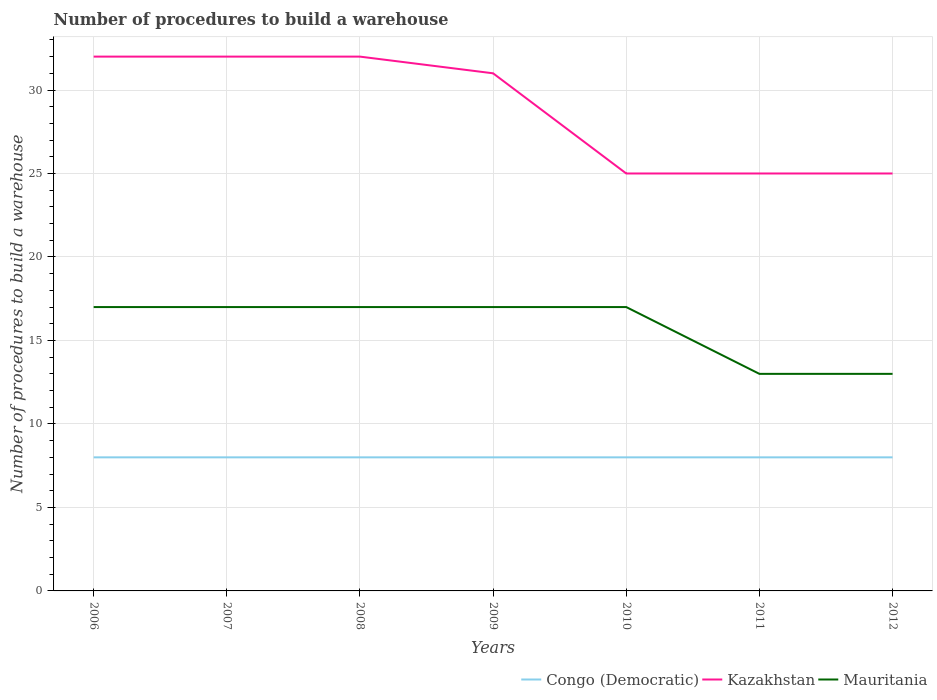Across all years, what is the maximum number of procedures to build a warehouse in in Kazakhstan?
Make the answer very short. 25. What is the total number of procedures to build a warehouse in in Kazakhstan in the graph?
Your response must be concise. 7. What is the difference between the highest and the second highest number of procedures to build a warehouse in in Mauritania?
Keep it short and to the point. 4. Is the number of procedures to build a warehouse in in Kazakhstan strictly greater than the number of procedures to build a warehouse in in Congo (Democratic) over the years?
Provide a succinct answer. No. Are the values on the major ticks of Y-axis written in scientific E-notation?
Offer a terse response. No. Does the graph contain any zero values?
Give a very brief answer. No. Does the graph contain grids?
Your answer should be very brief. Yes. Where does the legend appear in the graph?
Your answer should be very brief. Bottom right. How many legend labels are there?
Make the answer very short. 3. What is the title of the graph?
Offer a terse response. Number of procedures to build a warehouse. What is the label or title of the X-axis?
Provide a succinct answer. Years. What is the label or title of the Y-axis?
Your answer should be compact. Number of procedures to build a warehouse. What is the Number of procedures to build a warehouse in Congo (Democratic) in 2006?
Give a very brief answer. 8. What is the Number of procedures to build a warehouse of Mauritania in 2006?
Offer a terse response. 17. What is the Number of procedures to build a warehouse of Kazakhstan in 2008?
Your answer should be compact. 32. What is the Number of procedures to build a warehouse in Mauritania in 2008?
Your answer should be very brief. 17. What is the Number of procedures to build a warehouse in Congo (Democratic) in 2011?
Ensure brevity in your answer.  8. What is the Number of procedures to build a warehouse in Mauritania in 2011?
Give a very brief answer. 13. What is the Number of procedures to build a warehouse in Kazakhstan in 2012?
Give a very brief answer. 25. Across all years, what is the maximum Number of procedures to build a warehouse in Mauritania?
Your answer should be compact. 17. What is the total Number of procedures to build a warehouse in Congo (Democratic) in the graph?
Make the answer very short. 56. What is the total Number of procedures to build a warehouse in Kazakhstan in the graph?
Keep it short and to the point. 202. What is the total Number of procedures to build a warehouse of Mauritania in the graph?
Your response must be concise. 111. What is the difference between the Number of procedures to build a warehouse of Kazakhstan in 2006 and that in 2009?
Your answer should be very brief. 1. What is the difference between the Number of procedures to build a warehouse of Mauritania in 2006 and that in 2010?
Provide a short and direct response. 0. What is the difference between the Number of procedures to build a warehouse of Kazakhstan in 2006 and that in 2011?
Keep it short and to the point. 7. What is the difference between the Number of procedures to build a warehouse in Mauritania in 2006 and that in 2011?
Your answer should be compact. 4. What is the difference between the Number of procedures to build a warehouse of Congo (Democratic) in 2006 and that in 2012?
Your response must be concise. 0. What is the difference between the Number of procedures to build a warehouse of Mauritania in 2006 and that in 2012?
Offer a terse response. 4. What is the difference between the Number of procedures to build a warehouse in Congo (Democratic) in 2007 and that in 2008?
Your response must be concise. 0. What is the difference between the Number of procedures to build a warehouse of Congo (Democratic) in 2007 and that in 2009?
Your answer should be very brief. 0. What is the difference between the Number of procedures to build a warehouse of Congo (Democratic) in 2007 and that in 2010?
Make the answer very short. 0. What is the difference between the Number of procedures to build a warehouse in Kazakhstan in 2007 and that in 2011?
Offer a terse response. 7. What is the difference between the Number of procedures to build a warehouse in Mauritania in 2007 and that in 2011?
Offer a terse response. 4. What is the difference between the Number of procedures to build a warehouse in Congo (Democratic) in 2007 and that in 2012?
Provide a succinct answer. 0. What is the difference between the Number of procedures to build a warehouse in Congo (Democratic) in 2008 and that in 2009?
Provide a short and direct response. 0. What is the difference between the Number of procedures to build a warehouse of Congo (Democratic) in 2008 and that in 2012?
Offer a terse response. 0. What is the difference between the Number of procedures to build a warehouse of Kazakhstan in 2008 and that in 2012?
Your response must be concise. 7. What is the difference between the Number of procedures to build a warehouse in Congo (Democratic) in 2009 and that in 2010?
Give a very brief answer. 0. What is the difference between the Number of procedures to build a warehouse in Kazakhstan in 2009 and that in 2010?
Provide a succinct answer. 6. What is the difference between the Number of procedures to build a warehouse in Mauritania in 2009 and that in 2010?
Provide a succinct answer. 0. What is the difference between the Number of procedures to build a warehouse in Kazakhstan in 2009 and that in 2012?
Give a very brief answer. 6. What is the difference between the Number of procedures to build a warehouse in Congo (Democratic) in 2010 and that in 2011?
Offer a very short reply. 0. What is the difference between the Number of procedures to build a warehouse in Congo (Democratic) in 2010 and that in 2012?
Give a very brief answer. 0. What is the difference between the Number of procedures to build a warehouse in Kazakhstan in 2010 and that in 2012?
Provide a succinct answer. 0. What is the difference between the Number of procedures to build a warehouse of Congo (Democratic) in 2011 and that in 2012?
Your answer should be compact. 0. What is the difference between the Number of procedures to build a warehouse of Kazakhstan in 2011 and that in 2012?
Make the answer very short. 0. What is the difference between the Number of procedures to build a warehouse in Congo (Democratic) in 2006 and the Number of procedures to build a warehouse in Kazakhstan in 2007?
Ensure brevity in your answer.  -24. What is the difference between the Number of procedures to build a warehouse of Kazakhstan in 2006 and the Number of procedures to build a warehouse of Mauritania in 2007?
Offer a very short reply. 15. What is the difference between the Number of procedures to build a warehouse in Kazakhstan in 2006 and the Number of procedures to build a warehouse in Mauritania in 2008?
Provide a short and direct response. 15. What is the difference between the Number of procedures to build a warehouse in Congo (Democratic) in 2006 and the Number of procedures to build a warehouse in Kazakhstan in 2009?
Provide a short and direct response. -23. What is the difference between the Number of procedures to build a warehouse of Kazakhstan in 2006 and the Number of procedures to build a warehouse of Mauritania in 2009?
Provide a short and direct response. 15. What is the difference between the Number of procedures to build a warehouse in Congo (Democratic) in 2006 and the Number of procedures to build a warehouse in Kazakhstan in 2010?
Provide a short and direct response. -17. What is the difference between the Number of procedures to build a warehouse of Congo (Democratic) in 2006 and the Number of procedures to build a warehouse of Mauritania in 2010?
Keep it short and to the point. -9. What is the difference between the Number of procedures to build a warehouse of Kazakhstan in 2006 and the Number of procedures to build a warehouse of Mauritania in 2010?
Your answer should be very brief. 15. What is the difference between the Number of procedures to build a warehouse of Congo (Democratic) in 2006 and the Number of procedures to build a warehouse of Kazakhstan in 2012?
Provide a succinct answer. -17. What is the difference between the Number of procedures to build a warehouse of Congo (Democratic) in 2006 and the Number of procedures to build a warehouse of Mauritania in 2012?
Offer a terse response. -5. What is the difference between the Number of procedures to build a warehouse in Congo (Democratic) in 2007 and the Number of procedures to build a warehouse in Mauritania in 2008?
Provide a short and direct response. -9. What is the difference between the Number of procedures to build a warehouse in Congo (Democratic) in 2007 and the Number of procedures to build a warehouse in Kazakhstan in 2009?
Give a very brief answer. -23. What is the difference between the Number of procedures to build a warehouse of Congo (Democratic) in 2007 and the Number of procedures to build a warehouse of Mauritania in 2009?
Your answer should be compact. -9. What is the difference between the Number of procedures to build a warehouse of Congo (Democratic) in 2007 and the Number of procedures to build a warehouse of Kazakhstan in 2010?
Provide a succinct answer. -17. What is the difference between the Number of procedures to build a warehouse of Congo (Democratic) in 2007 and the Number of procedures to build a warehouse of Mauritania in 2010?
Offer a very short reply. -9. What is the difference between the Number of procedures to build a warehouse in Kazakhstan in 2007 and the Number of procedures to build a warehouse in Mauritania in 2010?
Give a very brief answer. 15. What is the difference between the Number of procedures to build a warehouse of Congo (Democratic) in 2007 and the Number of procedures to build a warehouse of Mauritania in 2011?
Make the answer very short. -5. What is the difference between the Number of procedures to build a warehouse in Congo (Democratic) in 2008 and the Number of procedures to build a warehouse in Kazakhstan in 2009?
Ensure brevity in your answer.  -23. What is the difference between the Number of procedures to build a warehouse in Congo (Democratic) in 2008 and the Number of procedures to build a warehouse in Mauritania in 2009?
Offer a terse response. -9. What is the difference between the Number of procedures to build a warehouse in Kazakhstan in 2008 and the Number of procedures to build a warehouse in Mauritania in 2009?
Keep it short and to the point. 15. What is the difference between the Number of procedures to build a warehouse in Congo (Democratic) in 2008 and the Number of procedures to build a warehouse in Kazakhstan in 2010?
Provide a short and direct response. -17. What is the difference between the Number of procedures to build a warehouse in Congo (Democratic) in 2008 and the Number of procedures to build a warehouse in Mauritania in 2010?
Keep it short and to the point. -9. What is the difference between the Number of procedures to build a warehouse in Kazakhstan in 2008 and the Number of procedures to build a warehouse in Mauritania in 2010?
Offer a very short reply. 15. What is the difference between the Number of procedures to build a warehouse in Congo (Democratic) in 2008 and the Number of procedures to build a warehouse in Kazakhstan in 2012?
Offer a very short reply. -17. What is the difference between the Number of procedures to build a warehouse of Congo (Democratic) in 2008 and the Number of procedures to build a warehouse of Mauritania in 2012?
Provide a succinct answer. -5. What is the difference between the Number of procedures to build a warehouse in Kazakhstan in 2008 and the Number of procedures to build a warehouse in Mauritania in 2012?
Give a very brief answer. 19. What is the difference between the Number of procedures to build a warehouse of Congo (Democratic) in 2009 and the Number of procedures to build a warehouse of Kazakhstan in 2010?
Provide a short and direct response. -17. What is the difference between the Number of procedures to build a warehouse in Congo (Democratic) in 2009 and the Number of procedures to build a warehouse in Mauritania in 2010?
Offer a terse response. -9. What is the difference between the Number of procedures to build a warehouse of Kazakhstan in 2009 and the Number of procedures to build a warehouse of Mauritania in 2010?
Keep it short and to the point. 14. What is the difference between the Number of procedures to build a warehouse in Congo (Democratic) in 2009 and the Number of procedures to build a warehouse in Kazakhstan in 2011?
Give a very brief answer. -17. What is the difference between the Number of procedures to build a warehouse of Congo (Democratic) in 2009 and the Number of procedures to build a warehouse of Mauritania in 2011?
Provide a short and direct response. -5. What is the difference between the Number of procedures to build a warehouse in Kazakhstan in 2009 and the Number of procedures to build a warehouse in Mauritania in 2011?
Offer a terse response. 18. What is the difference between the Number of procedures to build a warehouse in Congo (Democratic) in 2009 and the Number of procedures to build a warehouse in Kazakhstan in 2012?
Offer a terse response. -17. What is the difference between the Number of procedures to build a warehouse in Kazakhstan in 2009 and the Number of procedures to build a warehouse in Mauritania in 2012?
Your answer should be very brief. 18. What is the difference between the Number of procedures to build a warehouse of Congo (Democratic) in 2010 and the Number of procedures to build a warehouse of Mauritania in 2011?
Provide a short and direct response. -5. What is the difference between the Number of procedures to build a warehouse in Kazakhstan in 2010 and the Number of procedures to build a warehouse in Mauritania in 2011?
Offer a terse response. 12. What is the difference between the Number of procedures to build a warehouse of Congo (Democratic) in 2010 and the Number of procedures to build a warehouse of Mauritania in 2012?
Keep it short and to the point. -5. What is the difference between the Number of procedures to build a warehouse of Kazakhstan in 2010 and the Number of procedures to build a warehouse of Mauritania in 2012?
Make the answer very short. 12. What is the difference between the Number of procedures to build a warehouse in Congo (Democratic) in 2011 and the Number of procedures to build a warehouse in Kazakhstan in 2012?
Give a very brief answer. -17. What is the average Number of procedures to build a warehouse in Congo (Democratic) per year?
Keep it short and to the point. 8. What is the average Number of procedures to build a warehouse in Kazakhstan per year?
Give a very brief answer. 28.86. What is the average Number of procedures to build a warehouse of Mauritania per year?
Your response must be concise. 15.86. In the year 2006, what is the difference between the Number of procedures to build a warehouse of Congo (Democratic) and Number of procedures to build a warehouse of Kazakhstan?
Your response must be concise. -24. In the year 2006, what is the difference between the Number of procedures to build a warehouse in Congo (Democratic) and Number of procedures to build a warehouse in Mauritania?
Give a very brief answer. -9. In the year 2006, what is the difference between the Number of procedures to build a warehouse of Kazakhstan and Number of procedures to build a warehouse of Mauritania?
Ensure brevity in your answer.  15. In the year 2007, what is the difference between the Number of procedures to build a warehouse of Congo (Democratic) and Number of procedures to build a warehouse of Mauritania?
Make the answer very short. -9. In the year 2008, what is the difference between the Number of procedures to build a warehouse of Congo (Democratic) and Number of procedures to build a warehouse of Kazakhstan?
Your response must be concise. -24. In the year 2009, what is the difference between the Number of procedures to build a warehouse in Congo (Democratic) and Number of procedures to build a warehouse in Kazakhstan?
Keep it short and to the point. -23. In the year 2010, what is the difference between the Number of procedures to build a warehouse of Congo (Democratic) and Number of procedures to build a warehouse of Kazakhstan?
Make the answer very short. -17. In the year 2010, what is the difference between the Number of procedures to build a warehouse in Kazakhstan and Number of procedures to build a warehouse in Mauritania?
Make the answer very short. 8. In the year 2012, what is the difference between the Number of procedures to build a warehouse in Congo (Democratic) and Number of procedures to build a warehouse in Kazakhstan?
Your answer should be compact. -17. In the year 2012, what is the difference between the Number of procedures to build a warehouse of Congo (Democratic) and Number of procedures to build a warehouse of Mauritania?
Your answer should be compact. -5. In the year 2012, what is the difference between the Number of procedures to build a warehouse of Kazakhstan and Number of procedures to build a warehouse of Mauritania?
Provide a short and direct response. 12. What is the ratio of the Number of procedures to build a warehouse of Congo (Democratic) in 2006 to that in 2007?
Offer a very short reply. 1. What is the ratio of the Number of procedures to build a warehouse in Mauritania in 2006 to that in 2007?
Your answer should be compact. 1. What is the ratio of the Number of procedures to build a warehouse in Congo (Democratic) in 2006 to that in 2008?
Keep it short and to the point. 1. What is the ratio of the Number of procedures to build a warehouse of Mauritania in 2006 to that in 2008?
Your response must be concise. 1. What is the ratio of the Number of procedures to build a warehouse in Kazakhstan in 2006 to that in 2009?
Keep it short and to the point. 1.03. What is the ratio of the Number of procedures to build a warehouse of Mauritania in 2006 to that in 2009?
Your answer should be compact. 1. What is the ratio of the Number of procedures to build a warehouse in Congo (Democratic) in 2006 to that in 2010?
Offer a very short reply. 1. What is the ratio of the Number of procedures to build a warehouse of Kazakhstan in 2006 to that in 2010?
Offer a very short reply. 1.28. What is the ratio of the Number of procedures to build a warehouse in Congo (Democratic) in 2006 to that in 2011?
Your response must be concise. 1. What is the ratio of the Number of procedures to build a warehouse of Kazakhstan in 2006 to that in 2011?
Your answer should be very brief. 1.28. What is the ratio of the Number of procedures to build a warehouse in Mauritania in 2006 to that in 2011?
Give a very brief answer. 1.31. What is the ratio of the Number of procedures to build a warehouse of Congo (Democratic) in 2006 to that in 2012?
Offer a very short reply. 1. What is the ratio of the Number of procedures to build a warehouse in Kazakhstan in 2006 to that in 2012?
Ensure brevity in your answer.  1.28. What is the ratio of the Number of procedures to build a warehouse of Mauritania in 2006 to that in 2012?
Ensure brevity in your answer.  1.31. What is the ratio of the Number of procedures to build a warehouse in Congo (Democratic) in 2007 to that in 2008?
Make the answer very short. 1. What is the ratio of the Number of procedures to build a warehouse in Kazakhstan in 2007 to that in 2008?
Make the answer very short. 1. What is the ratio of the Number of procedures to build a warehouse of Mauritania in 2007 to that in 2008?
Offer a very short reply. 1. What is the ratio of the Number of procedures to build a warehouse in Kazakhstan in 2007 to that in 2009?
Give a very brief answer. 1.03. What is the ratio of the Number of procedures to build a warehouse of Kazakhstan in 2007 to that in 2010?
Ensure brevity in your answer.  1.28. What is the ratio of the Number of procedures to build a warehouse in Mauritania in 2007 to that in 2010?
Provide a short and direct response. 1. What is the ratio of the Number of procedures to build a warehouse of Congo (Democratic) in 2007 to that in 2011?
Make the answer very short. 1. What is the ratio of the Number of procedures to build a warehouse in Kazakhstan in 2007 to that in 2011?
Your answer should be very brief. 1.28. What is the ratio of the Number of procedures to build a warehouse of Mauritania in 2007 to that in 2011?
Your response must be concise. 1.31. What is the ratio of the Number of procedures to build a warehouse in Kazakhstan in 2007 to that in 2012?
Give a very brief answer. 1.28. What is the ratio of the Number of procedures to build a warehouse in Mauritania in 2007 to that in 2012?
Make the answer very short. 1.31. What is the ratio of the Number of procedures to build a warehouse in Kazakhstan in 2008 to that in 2009?
Your answer should be compact. 1.03. What is the ratio of the Number of procedures to build a warehouse in Kazakhstan in 2008 to that in 2010?
Ensure brevity in your answer.  1.28. What is the ratio of the Number of procedures to build a warehouse of Mauritania in 2008 to that in 2010?
Your answer should be very brief. 1. What is the ratio of the Number of procedures to build a warehouse of Kazakhstan in 2008 to that in 2011?
Provide a short and direct response. 1.28. What is the ratio of the Number of procedures to build a warehouse of Mauritania in 2008 to that in 2011?
Offer a very short reply. 1.31. What is the ratio of the Number of procedures to build a warehouse in Congo (Democratic) in 2008 to that in 2012?
Offer a terse response. 1. What is the ratio of the Number of procedures to build a warehouse of Kazakhstan in 2008 to that in 2012?
Provide a succinct answer. 1.28. What is the ratio of the Number of procedures to build a warehouse in Mauritania in 2008 to that in 2012?
Provide a short and direct response. 1.31. What is the ratio of the Number of procedures to build a warehouse in Congo (Democratic) in 2009 to that in 2010?
Provide a succinct answer. 1. What is the ratio of the Number of procedures to build a warehouse in Kazakhstan in 2009 to that in 2010?
Your response must be concise. 1.24. What is the ratio of the Number of procedures to build a warehouse of Kazakhstan in 2009 to that in 2011?
Provide a short and direct response. 1.24. What is the ratio of the Number of procedures to build a warehouse in Mauritania in 2009 to that in 2011?
Make the answer very short. 1.31. What is the ratio of the Number of procedures to build a warehouse of Kazakhstan in 2009 to that in 2012?
Ensure brevity in your answer.  1.24. What is the ratio of the Number of procedures to build a warehouse of Mauritania in 2009 to that in 2012?
Your response must be concise. 1.31. What is the ratio of the Number of procedures to build a warehouse of Congo (Democratic) in 2010 to that in 2011?
Your response must be concise. 1. What is the ratio of the Number of procedures to build a warehouse in Kazakhstan in 2010 to that in 2011?
Offer a very short reply. 1. What is the ratio of the Number of procedures to build a warehouse of Mauritania in 2010 to that in 2011?
Ensure brevity in your answer.  1.31. What is the ratio of the Number of procedures to build a warehouse of Mauritania in 2010 to that in 2012?
Your answer should be compact. 1.31. What is the ratio of the Number of procedures to build a warehouse of Kazakhstan in 2011 to that in 2012?
Provide a short and direct response. 1. What is the ratio of the Number of procedures to build a warehouse of Mauritania in 2011 to that in 2012?
Your answer should be compact. 1. What is the difference between the highest and the second highest Number of procedures to build a warehouse in Mauritania?
Offer a very short reply. 0. What is the difference between the highest and the lowest Number of procedures to build a warehouse in Kazakhstan?
Your answer should be very brief. 7. 